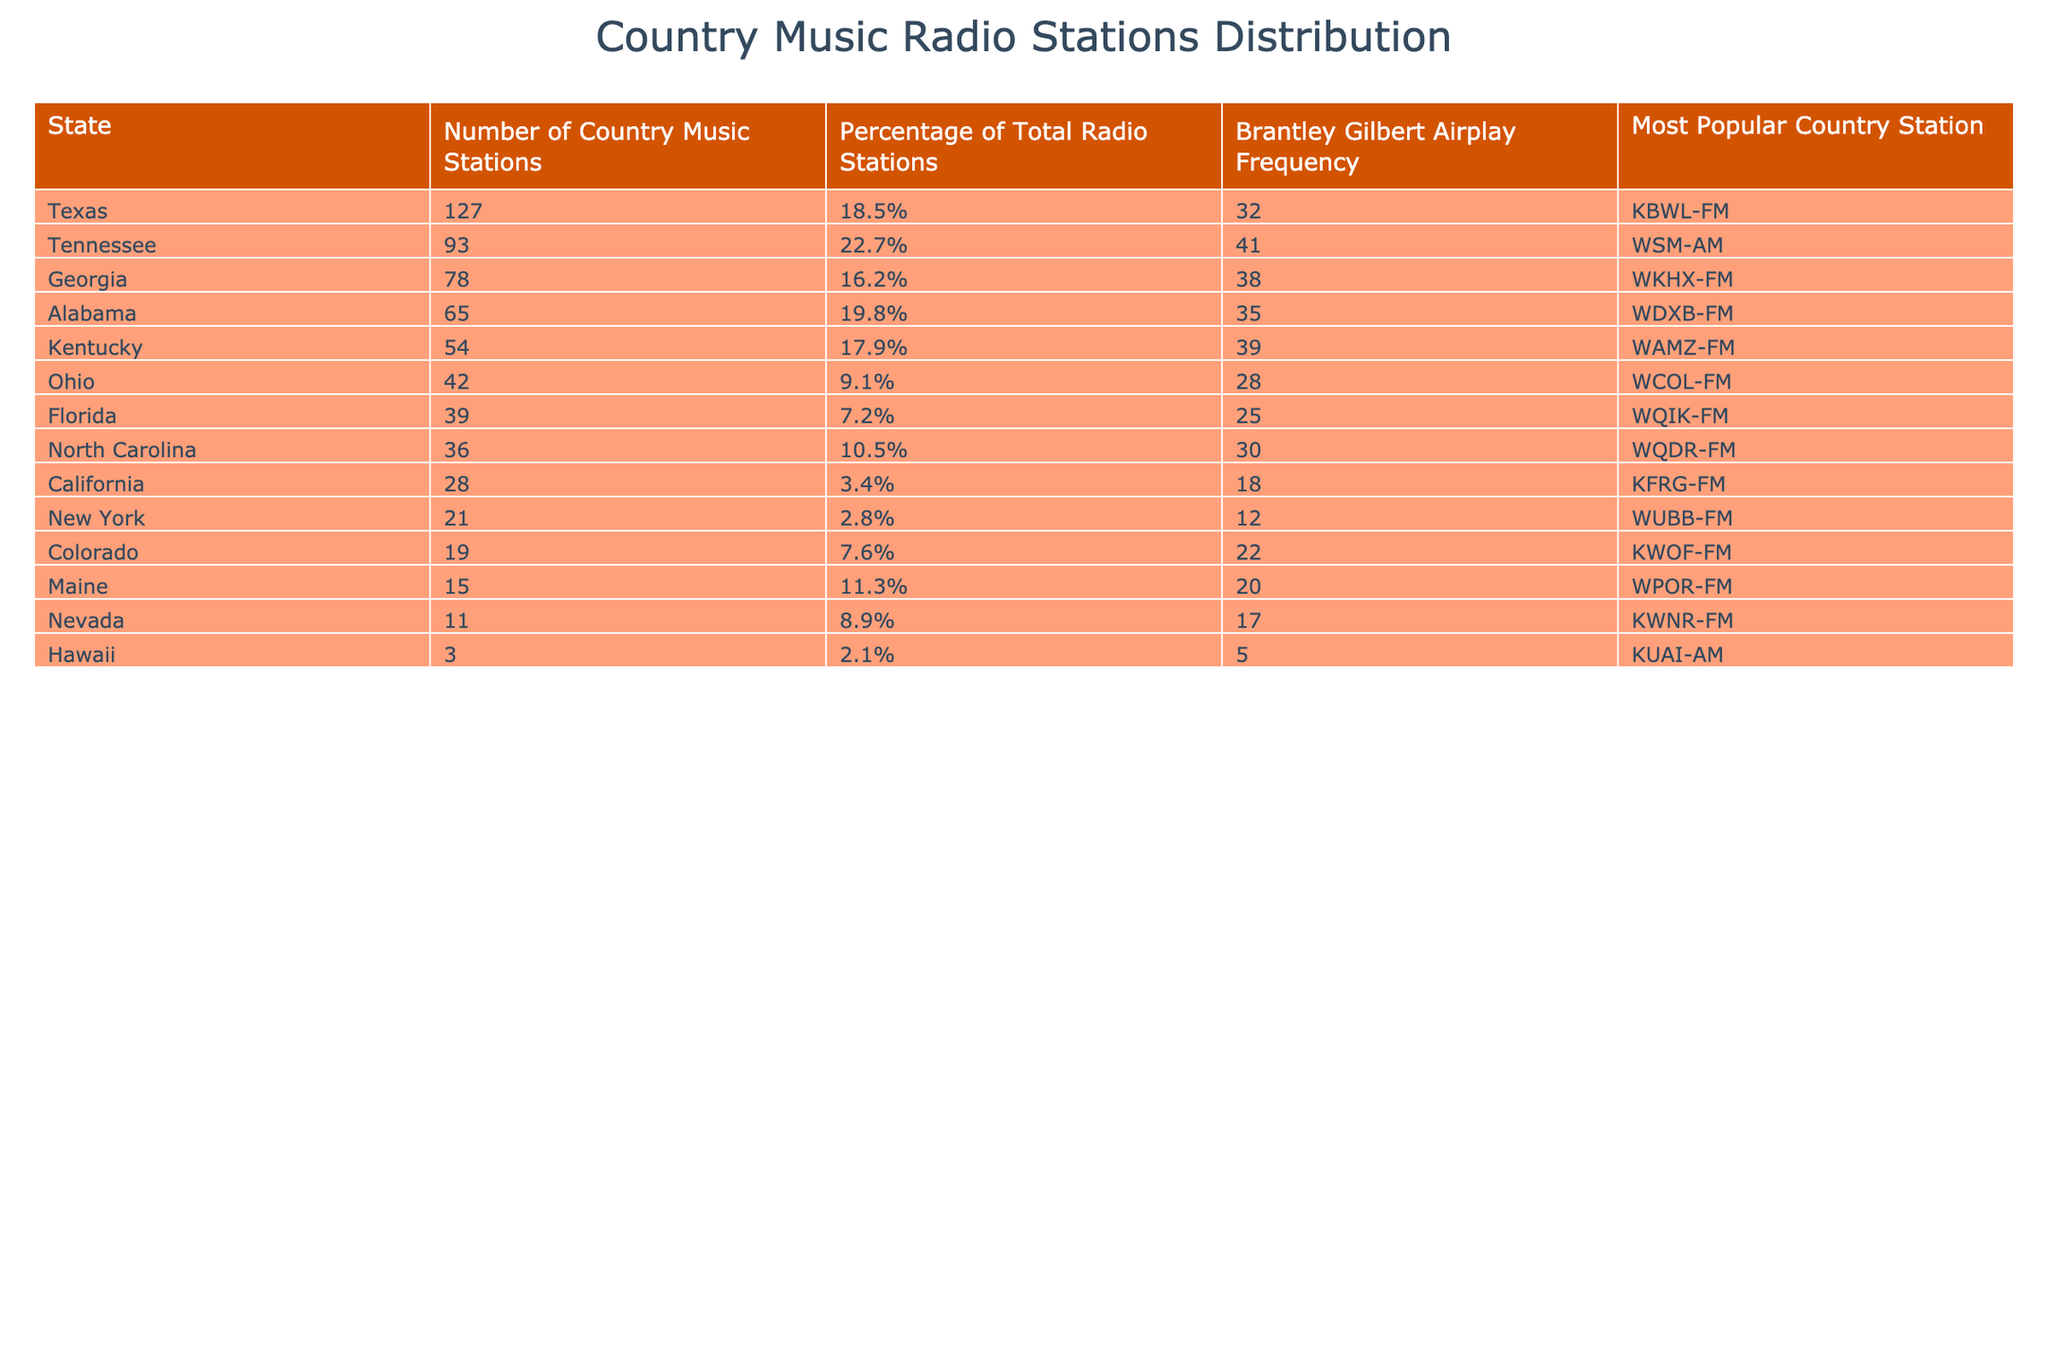What state has the highest number of country music stations? Texas has the highest number of country music stations at 127. This can be directly found in the "Number of Country Music Stations" column.
Answer: Texas Which state has the lowest percentage of total radio stations dedicated to country music? California has the lowest percentage at 3.4%, as seen in the "Percentage of Total Radio Stations" column.
Answer: California How many country music stations are there in Tennessee? Tennessee has 93 country music stations, which is directly listed in the table.
Answer: 93 What is the airplay frequency of Brantley Gilbert in Florida? The airplay frequency of Brantley Gilbert in Florida is 25, found in the "Brantley Gilbert Airplay Frequency" column for Florida.
Answer: 25 What is the average percentage of total radio stations dedicated to country music across all the states listed? First, we sum the percentages: 18.5 + 22.7 + 16.2 + 19.8 + 17.9 + 9.1 + 7.2 + 10.5 + 3.4 + 2.8 + 7.6 + 11.3 + 8.9 + 2.1 =  144.5. There are 14 states, so the average is 144.5 / 14 = 10.36%.
Answer: 10.36% True or false: New York has more country music stations than Ohio. New York has 21 country music stations, while Ohio has 42. Therefore, the statement is false.
Answer: False What is the most popular country station in Alabama? The most popular country station in Alabama is WDXB-FM, as indicated in the "Most Popular Country Station" column for that state.
Answer: WDXB-FM How many more country music stations does Texas have than California? Texas has 127 stations and California has 28. The difference is 127 - 28 = 99.
Answer: 99 What is the total number of country music stations in North Carolina and Kentucky combined? North Carolina has 36 stations and Kentucky has 54. The sum is 36 + 54 = 90.
Answer: 90 Which state has a higher Brantley Gilbert airplay frequency, Georgia or Alabama? Georgia has an airplay frequency of 38, while Alabama has 35. Georgia has the higher airplay frequency.
Answer: Georgia Is the percentage of total radio stations dedicated to country music in Georgia higher than in Florida? Georgia's percentage is 16.2%, while Florida's is 7.2%. Therefore, Georgia's percentage is indeed higher.
Answer: Yes 